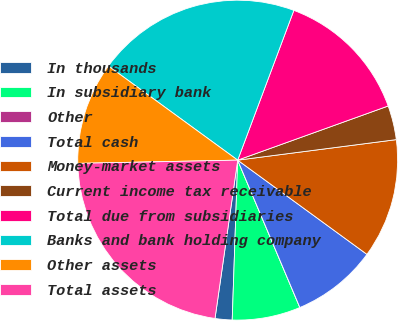<chart> <loc_0><loc_0><loc_500><loc_500><pie_chart><fcel>In thousands<fcel>In subsidiary bank<fcel>Other<fcel>Total cash<fcel>Money-market assets<fcel>Current income tax receivable<fcel>Total due from subsidiaries<fcel>Banks and bank holding company<fcel>Other assets<fcel>Total assets<nl><fcel>1.72%<fcel>6.9%<fcel>0.0%<fcel>8.62%<fcel>12.07%<fcel>3.45%<fcel>13.79%<fcel>20.69%<fcel>10.34%<fcel>22.41%<nl></chart> 